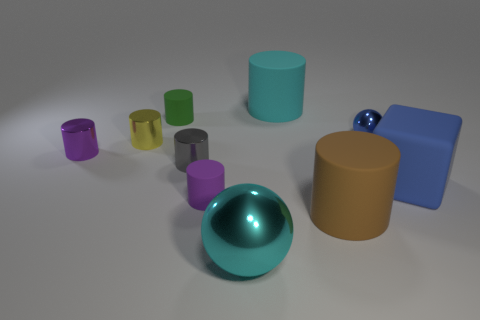Subtract all brown cylinders. How many cylinders are left? 6 Subtract all gray cylinders. How many cylinders are left? 6 Subtract all purple cylinders. Subtract all yellow blocks. How many cylinders are left? 5 Subtract all cylinders. How many objects are left? 3 Add 4 tiny purple cylinders. How many tiny purple cylinders are left? 6 Add 3 large blue rubber objects. How many large blue rubber objects exist? 4 Subtract 0 brown spheres. How many objects are left? 10 Subtract all tiny green metal blocks. Subtract all tiny purple metallic cylinders. How many objects are left? 9 